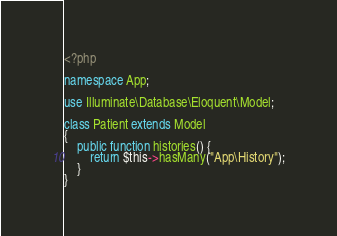Convert code to text. <code><loc_0><loc_0><loc_500><loc_500><_PHP_><?php

namespace App;

use Illuminate\Database\Eloquent\Model;

class Patient extends Model
{
    public function histories() {
		return $this->hasMany("App\History");
	}
}
</code> 